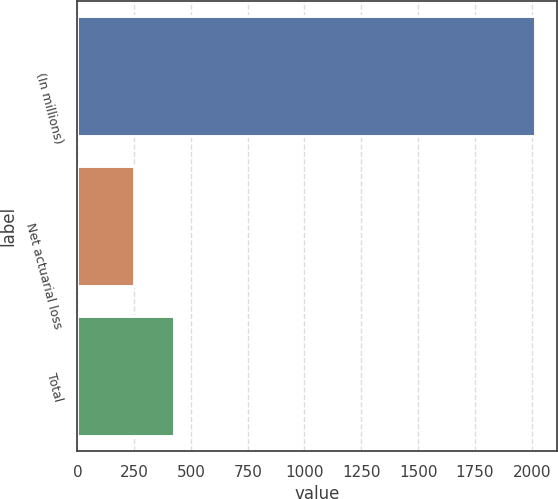<chart> <loc_0><loc_0><loc_500><loc_500><bar_chart><fcel>(In millions)<fcel>Net actuarial loss<fcel>Total<nl><fcel>2013<fcel>251<fcel>427.2<nl></chart> 